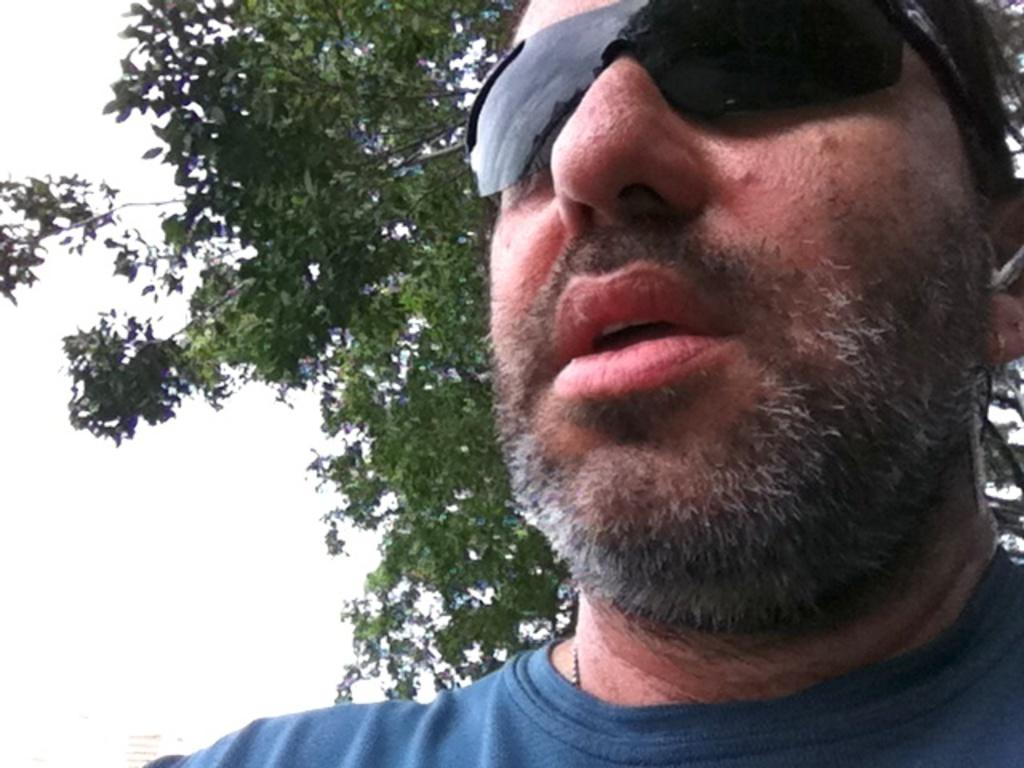What is the main subject of the image? There is a person's face in the image. What accessory is the person wearing in the image? The person is wearing spectacles. What type of natural element can be seen in the image? There is a tree visible in the image. What type of letter is the person holding in the image? There is no letter present in the image; it only features a person's face and spectacles. What sound can be heard from the bells in the image? There are no bells present in the image, so no sound can be heard. 